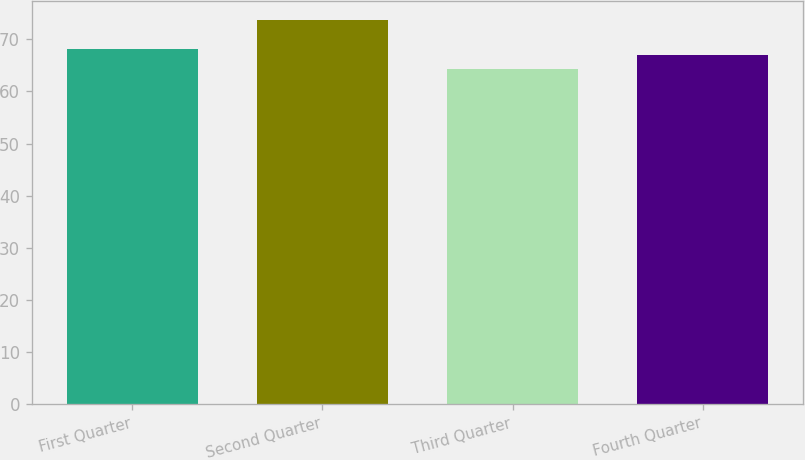Convert chart to OTSL. <chart><loc_0><loc_0><loc_500><loc_500><bar_chart><fcel>First Quarter<fcel>Second Quarter<fcel>Third Quarter<fcel>Fourth Quarter<nl><fcel>68.24<fcel>73.66<fcel>64.4<fcel>67<nl></chart> 